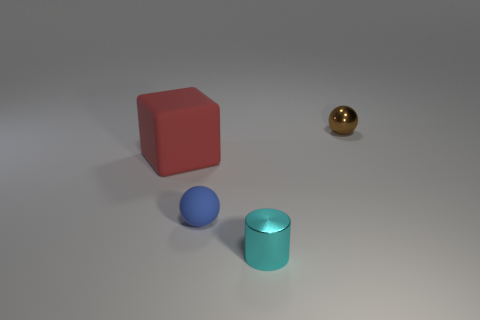Add 3 cyan cylinders. How many objects exist? 7 Subtract all brown spheres. How many spheres are left? 1 Subtract 1 blue balls. How many objects are left? 3 Subtract all cylinders. How many objects are left? 3 Subtract all big red matte cubes. Subtract all big blue objects. How many objects are left? 3 Add 2 cyan things. How many cyan things are left? 3 Add 4 large green matte cylinders. How many large green matte cylinders exist? 4 